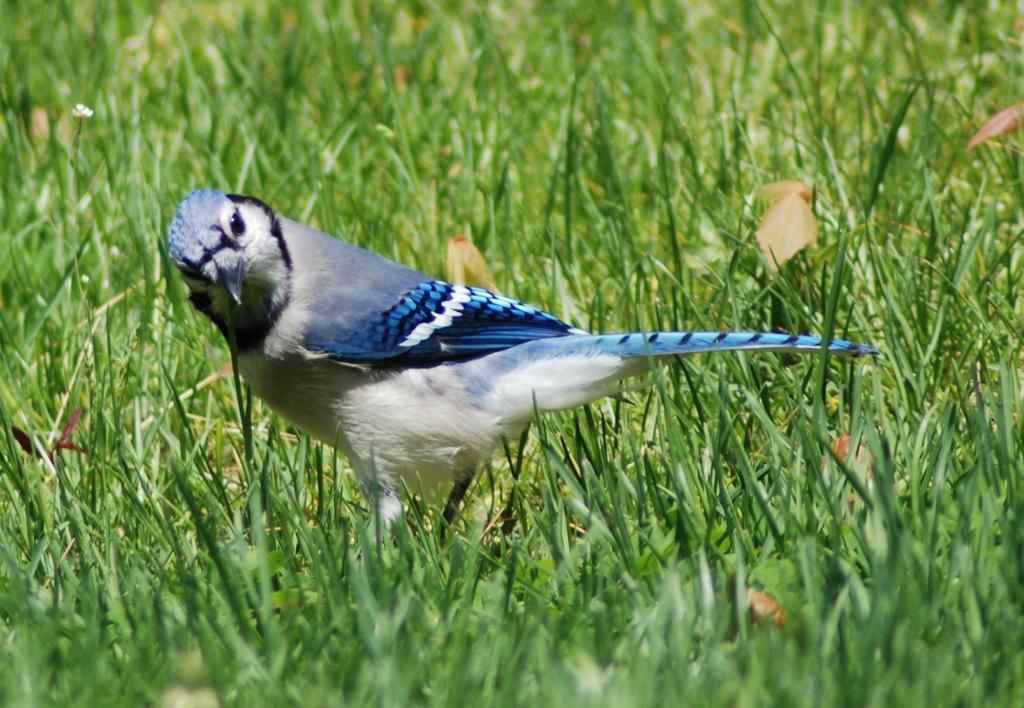How would you summarize this image in a sentence or two? In this image there is a bird standing on the ground. There is a grass on the ground. 